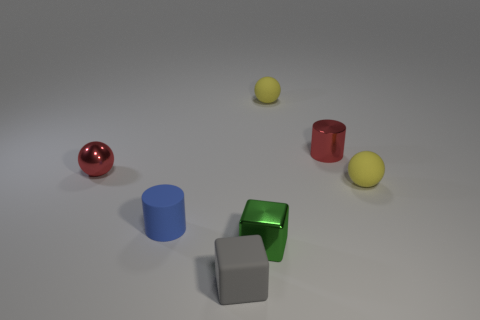Can you describe the shapes and colors of the objects in this image? Certainly! There are six objects in total: a red sphere, a red cylinder, a yellow sphere, a yellow sphere slightly larger than the first, a blue cylinder, and a green cube. Additionally, there's a grey cube that adds a neutral tone to the mix. 